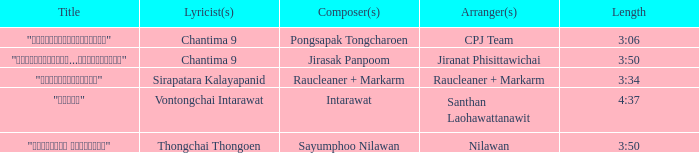Who was the arranger of "ขอโทษ"? Santhan Laohawattanawit. 